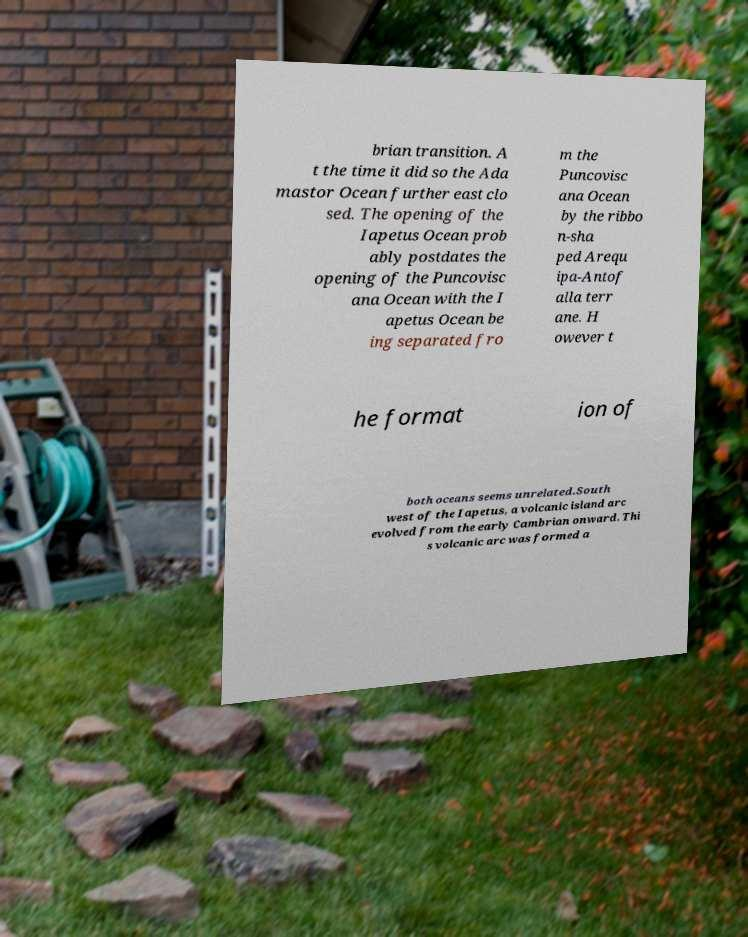For documentation purposes, I need the text within this image transcribed. Could you provide that? brian transition. A t the time it did so the Ada mastor Ocean further east clo sed. The opening of the Iapetus Ocean prob ably postdates the opening of the Puncovisc ana Ocean with the I apetus Ocean be ing separated fro m the Puncovisc ana Ocean by the ribbo n-sha ped Arequ ipa-Antof alla terr ane. H owever t he format ion of both oceans seems unrelated.South west of the Iapetus, a volcanic island arc evolved from the early Cambrian onward. Thi s volcanic arc was formed a 